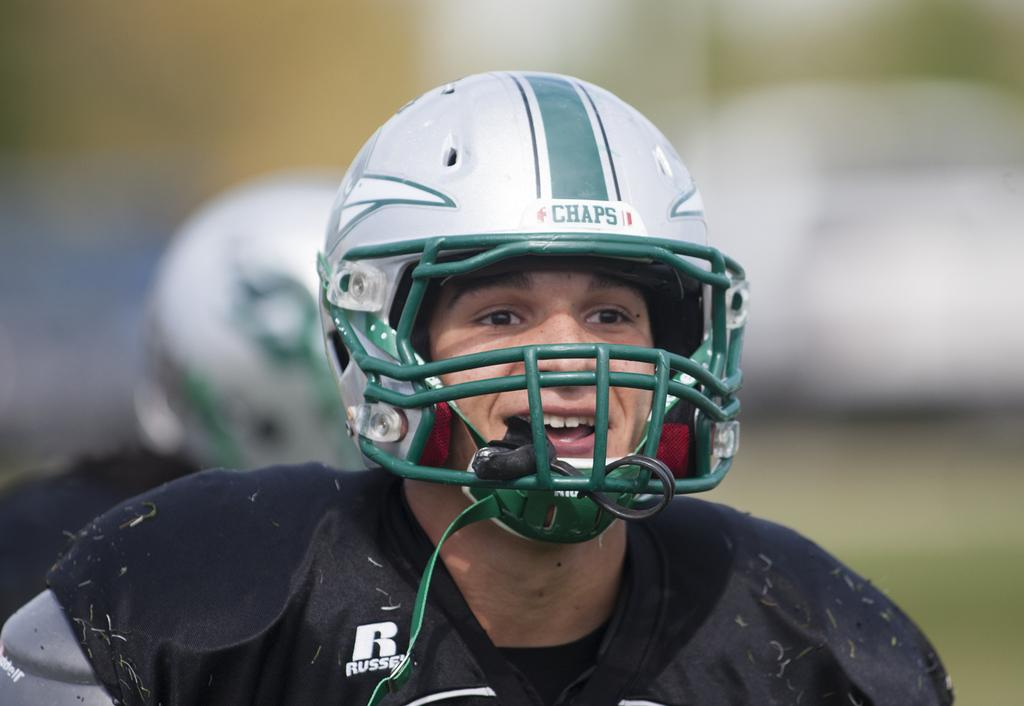Who is present in the image? There is a man in the image. What is the man wearing on his head? The man is wearing a helmet. Can you describe the background of the image? The background of the image is blurred. What type of selection process is being conducted in the image? There is no indication of a selection process in the image; it features a man wearing a helmet with a blurred background. 